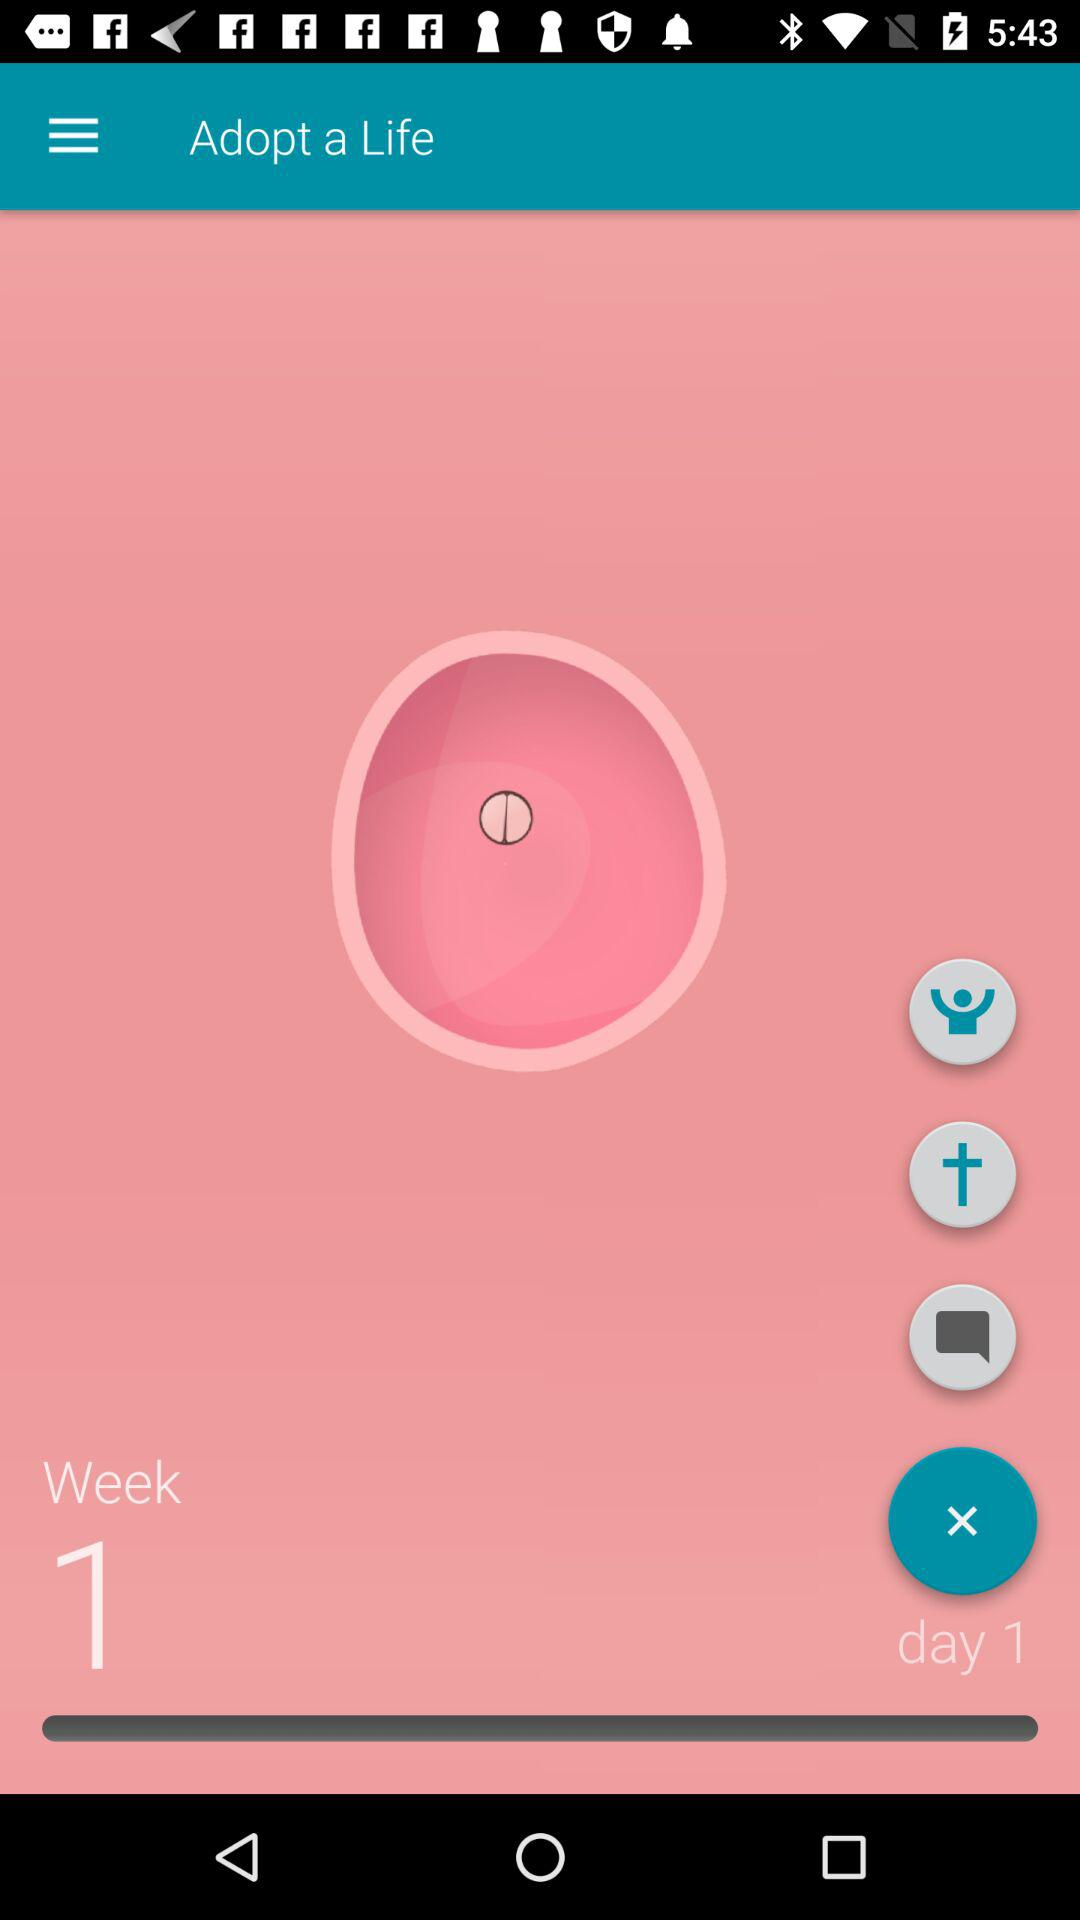What day is it? It is day 1. 